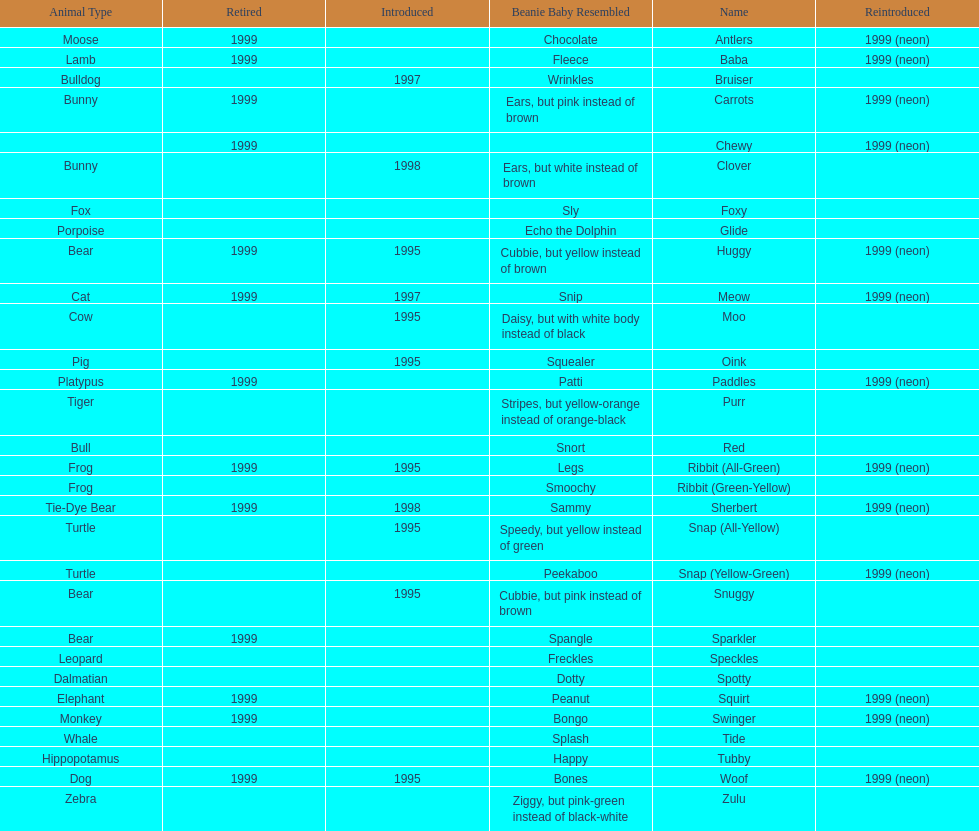Which is the only pillow pal without a listed animal type? Chewy. 